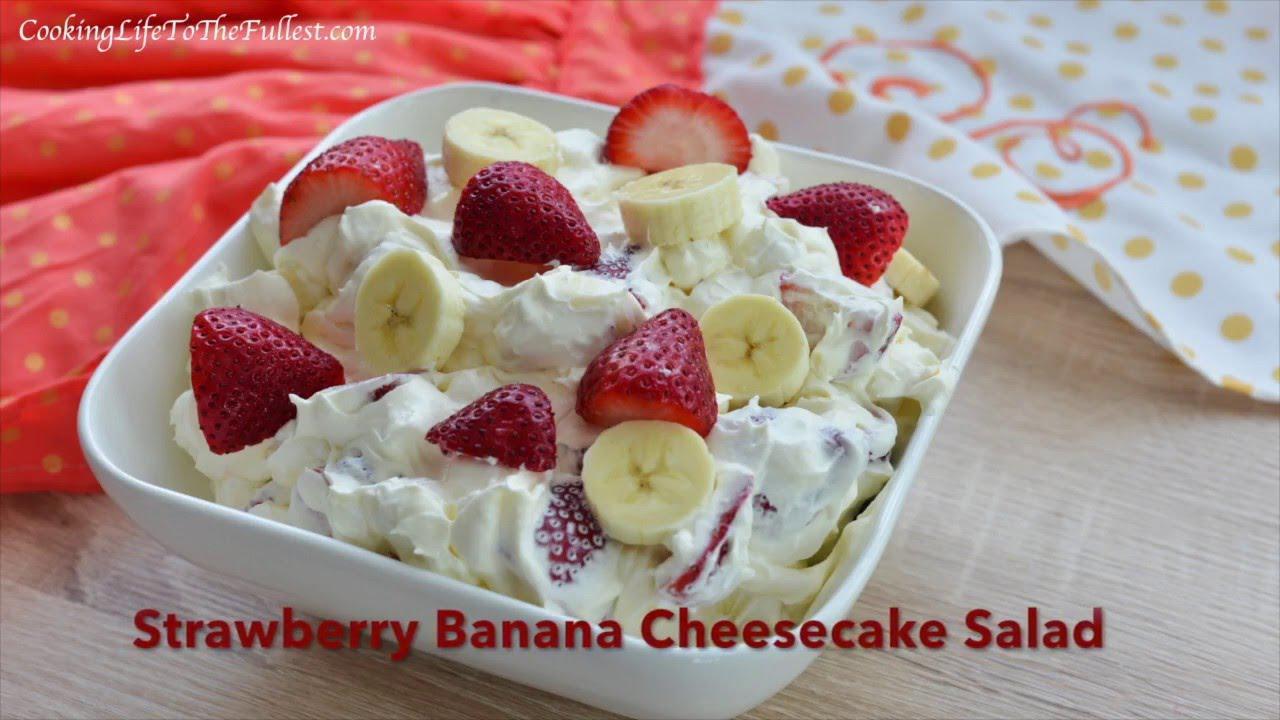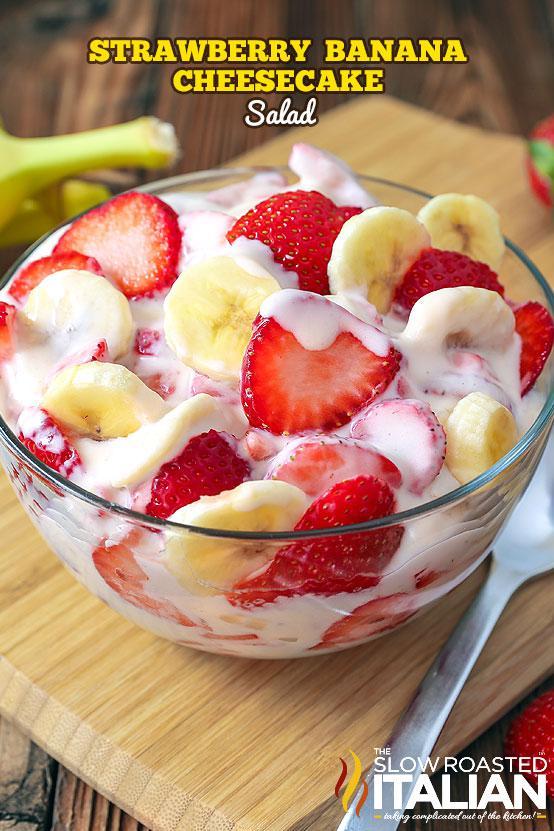The first image is the image on the left, the second image is the image on the right. Analyze the images presented: Is the assertion "An image shows a bowl topped with strawberry and a green leafy spring." valid? Answer yes or no. No. The first image is the image on the left, the second image is the image on the right. For the images displayed, is the sentence "There is cutlery outside of the bowl." factually correct? Answer yes or no. Yes. The first image is the image on the left, the second image is the image on the right. For the images shown, is this caption "An image shows a round bowl of fruit dessert sitting on a wood-grain board, with a piece of silverware laying flat on the right side of the bowl." true? Answer yes or no. Yes. The first image is the image on the left, the second image is the image on the right. For the images shown, is this caption "There is an eating utensil next to a bowl of fruit salad." true? Answer yes or no. Yes. 